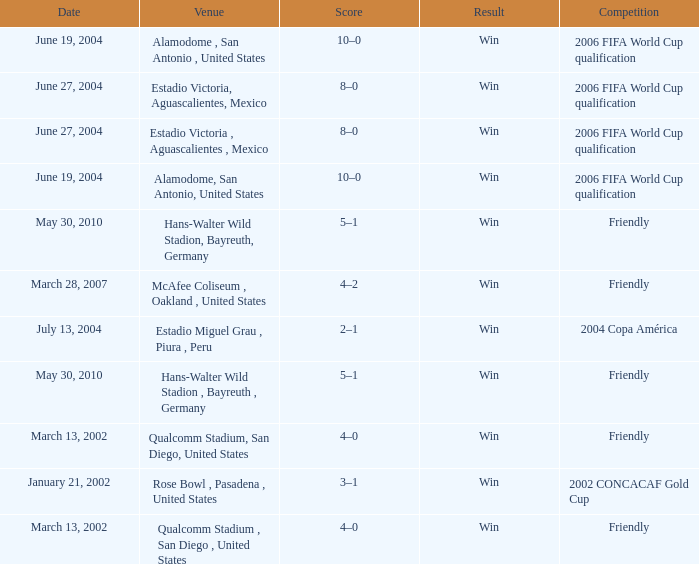What result has January 21, 2002 as the date? Win. 